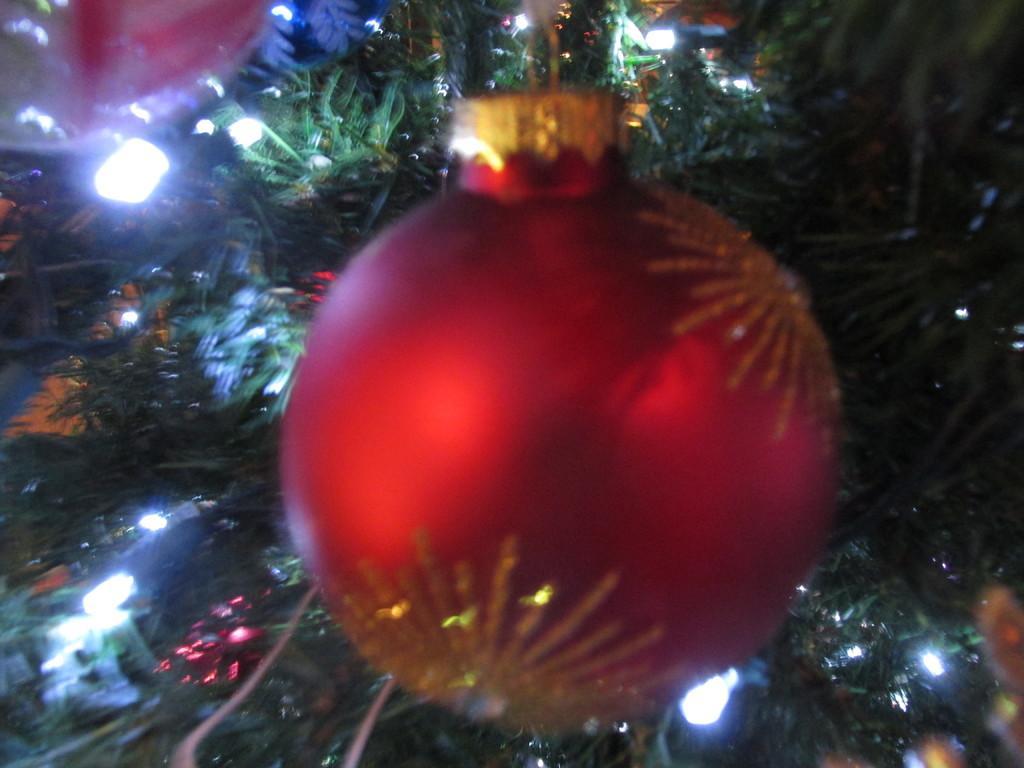In one or two sentences, can you explain what this image depicts? In the image there is a christmas with lights and decoration balls hanging to it. 